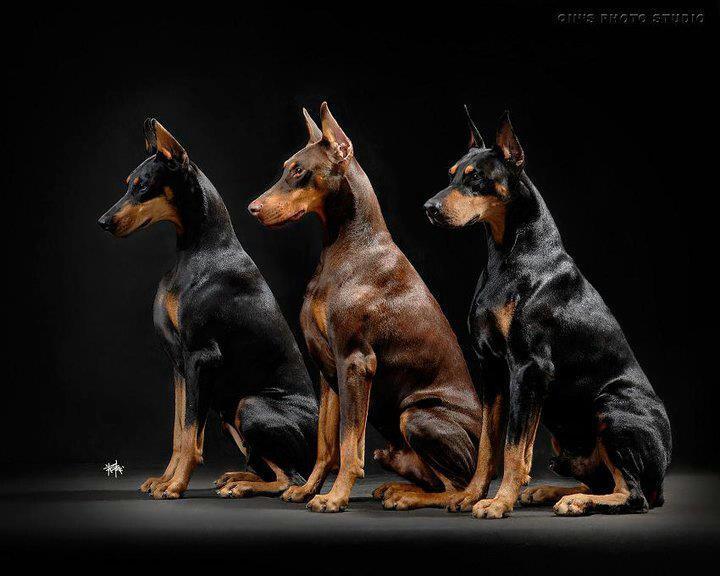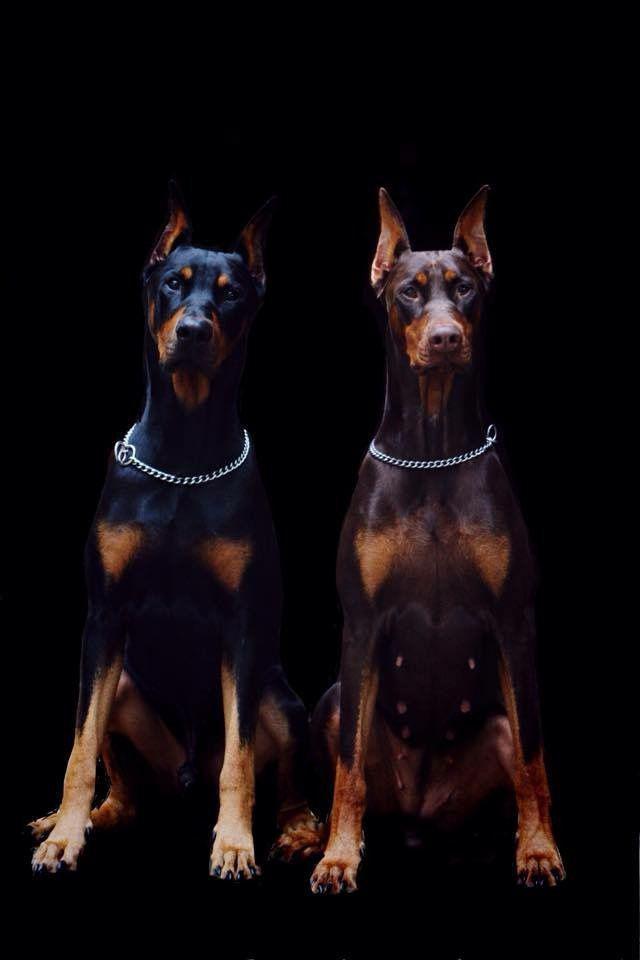The first image is the image on the left, the second image is the image on the right. Examine the images to the left and right. Is the description "The combined images include at least four dogs, with at least two dogs in sitting poses and two dogs facing directly forward." accurate? Answer yes or no. Yes. 